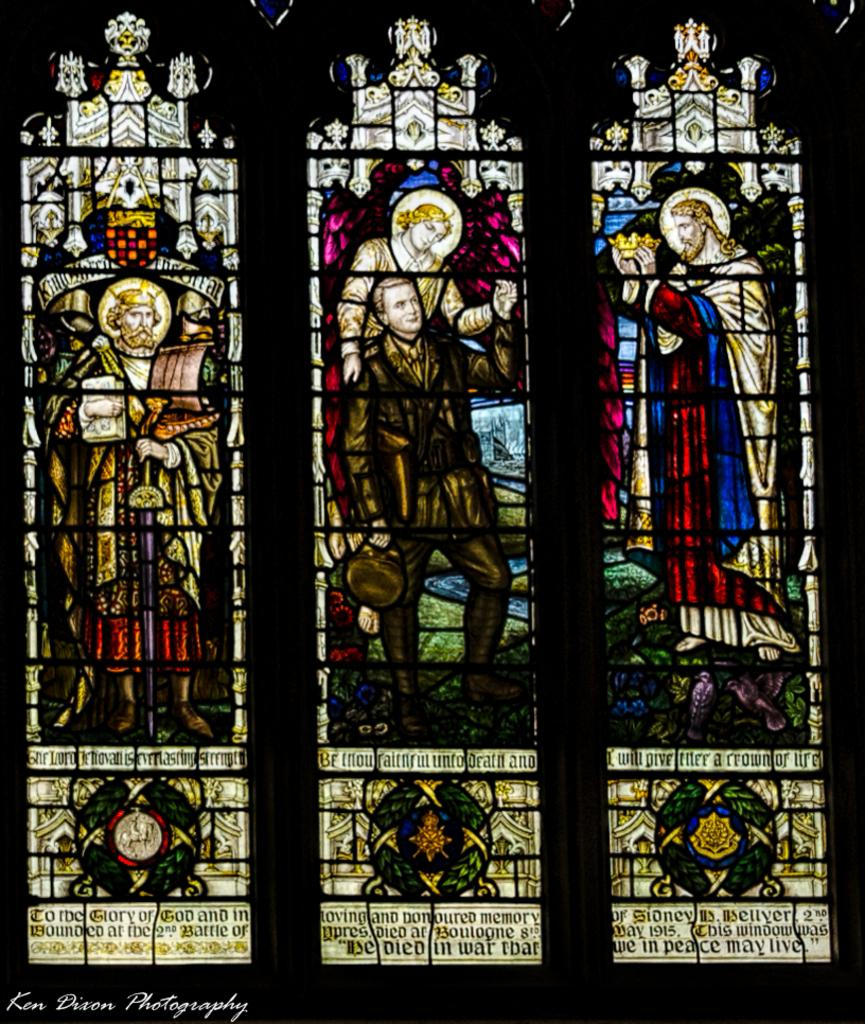What is on the glass in the image? There are pictures on the glass in the image. What else can be seen in the image besides the pictures on the glass? There is text visible in the image. How many rabbits are helping the expert in the image? There are no rabbits or experts present in the image. 